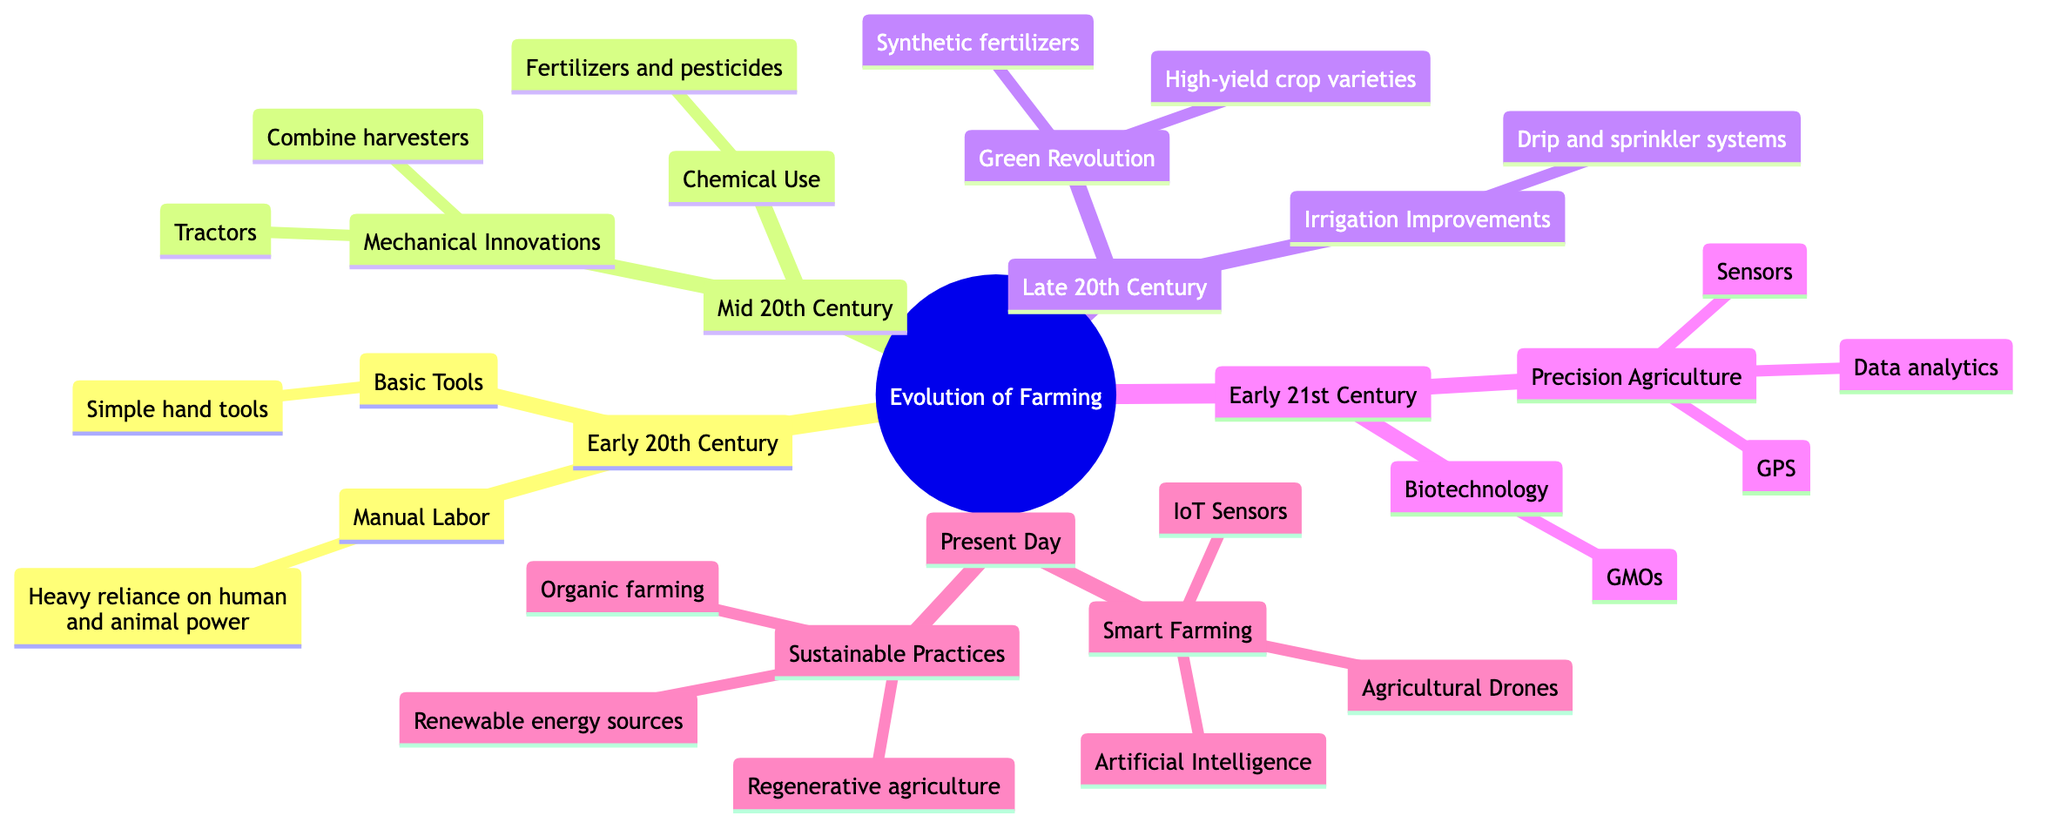What major innovations marked the Mid 20th Century? The Mid 20th Century is associated with "Mechanical Innovations" and "Chemical Use." "Mechanical Innovations" includes the introduction of tractors and combine harvesters, while "Chemical Use" signifies increased use of fertilizers and pesticides.
Answer: Mechanical Innovations, Chemical Use Who is a key figure associated with the Green Revolution? The diagram indicates that Norman Borlaug is a key figure associated with the Green Revolution, which is noted for adopting high-yield crop varieties.
Answer: Norman Borlaug What technologies are integrated in Smart Farming? The Smart Farming section lists several technologies including IoT Sensors, Agricultural Drones, and Artificial Intelligence. Hence, these are the technologies integrated in Smart Farming.
Answer: IoT Sensors, Agricultural Drones, Artificial Intelligence How did farming techniques change from the Early 20th Century to the Present Day? The transition from the Early 20th Century to the Present Day includes advancements from manual labor and basic tools to sophisticated systems such as Smart Farming and Sustainable Practices, showcasing significant evolution in techniques and technologies used in farming.
Answer: Significant evolution How many categories are present in the Early 21st Century? The Early 21st Century has two categories, "Precision Agriculture" and "Biotechnology." Therefore, the count of categories in this era is two.
Answer: 2 What irrigation improvements were made in the Late 20th Century? The diagram specifically notes advancements in irrigation techniques such as drip and sprinkler systems that were developed during the Late 20th Century.
Answer: Drip and sprinkler systems Which technological development relates to the use of GPS? "Precision Agriculture" is the category in the Early 21st Century that mentions the use of GPS, indicating the specific technology development related to GPS.
Answer: Precision Agriculture What is the main focus of Sustainable Practices in the Present Day? The focus of Sustainable Practices is to reduce environmental impact through methods like organic farming, regenerative agriculture, and the use of renewable energy sources. This indicates a significant commitment to environmentally friendly farming.
Answer: Reducing environmental impact 